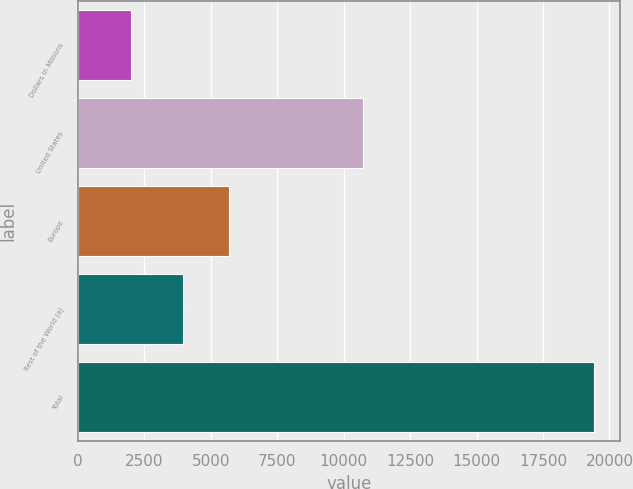Convert chart to OTSL. <chart><loc_0><loc_0><loc_500><loc_500><bar_chart><fcel>Dollars in Millions<fcel>United States<fcel>Europe<fcel>Rest of the World (a)<fcel>Total<nl><fcel>2016<fcel>10720<fcel>5705.1<fcel>3964<fcel>19427<nl></chart> 